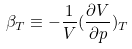<formula> <loc_0><loc_0><loc_500><loc_500>\beta _ { T } \equiv - \frac { 1 } { V } ( \frac { \partial V } { \partial p } ) _ { T }</formula> 